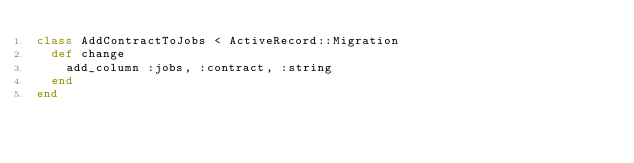Convert code to text. <code><loc_0><loc_0><loc_500><loc_500><_Ruby_>class AddContractToJobs < ActiveRecord::Migration
  def change
    add_column :jobs, :contract, :string
  end
end
</code> 